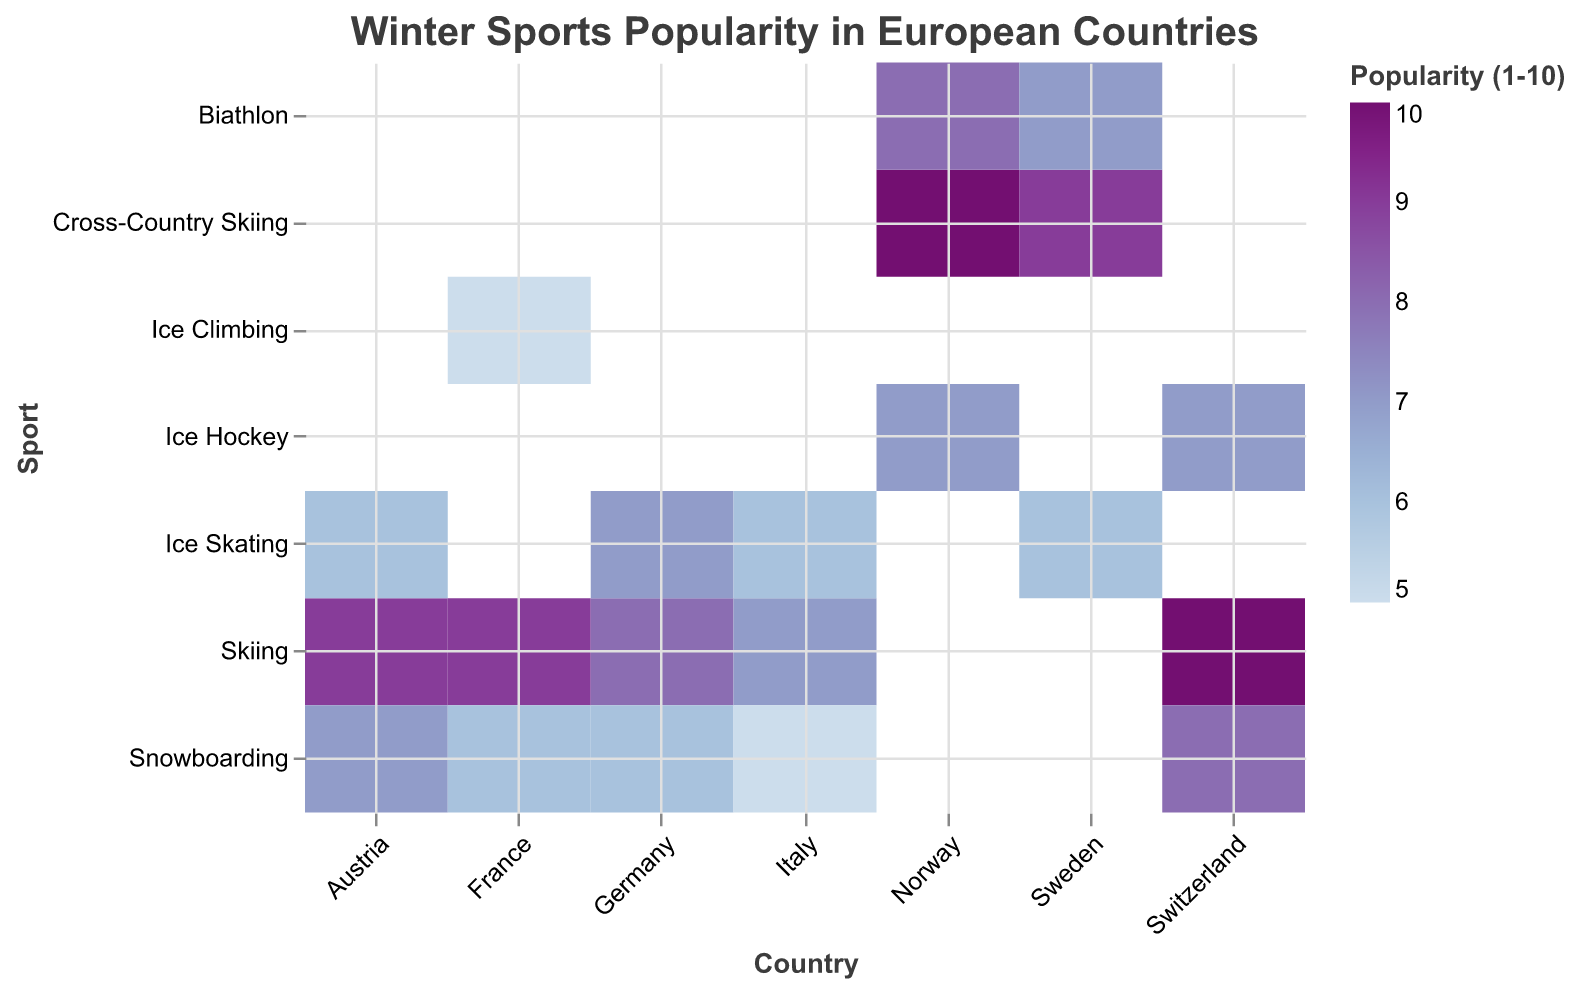What is the most popular winter sport in Norway? The popularity values for winter sports in Norway are 10 for Cross-Country Skiing, 8 for Biathlon, and 7 for Ice Hockey. The highest value is 10 for Cross-Country Skiing.
Answer: Cross-Country Skiing Which country has the highest popularity for Skiing? The popularity of Skiing is 9 in Austria, 10 in Switzerland, 9 in France, 8 in Germany, and 7 in Italy. Switzerland has the highest popularity value of 10.
Answer: Switzerland What are the least popular winter sports in France? The popularity values for winter sports in France are Skiing (9), Snowboarding (6), and Ice Climbing (5). Ice Climbing has the lowest value, which is 5.
Answer: Ice Climbing How does the popularity of Snowboarding in Austria compare to that in Germany? The popularity value for Snowboarding is 7 in Austria and 6 in Germany. Since 7 is greater than 6, Snowboarding is more popular in Austria than in Germany.
Answer: More popular in Austria What is the average popularity of winter sports in Sweden? The popularity values for winter sports in Sweden are Cross-Country Skiing (9), Biathlon (7), and Ice Skating (6). The average is calculated as (9 + 7 + 6) / 3 = 22 / 3 = 7.33.
Answer: 7.33 Which country has more popular winter sports overall, France or Italy? The popularity values for winter sports in France are Skiing (9), Snowboarding (6), and Ice Climbing (5). The total is 9 + 6 + 5 = 20. For Italy, the values are Skiing (7), Snowboarding (5), and Ice Skating (6). The total is 7 + 5 + 6 = 18. France has an overall higher popularity score.
Answer: France Is Ice Hockey more popular in Switzerland or Norway? The popularity value for Ice Hockey is 7 in both Switzerland and Norway. Since both have the same value, Ice Hockey is equally popular in both.
Answer: Equally popular Which sport has the highest popularity value across all countries? By looking at all the popularity values, Skiing in Switzerland and Cross-Country Skiing in Norway both have the highest value of 10.
Answer: Skiing and Cross-Country Skiing What's the difference in popularity between Skiing and Snowboarding in Austria? The popularity value for Skiing in Austria is 9, and for Snowboarding, it is 7. The difference is 9 - 7 = 2.
Answer: 2 Which of the countries represented has the widest range of popularity across its winter sports? The ranges for each country are: Austria (3), Switzerland (3), France (4), Germany (2), Italy (2), Norway (3), Sweden (3). France has the widest range in popularity, from 9 for Skiing to 5 for Ice Climbing, which is a range of 4.
Answer: France 